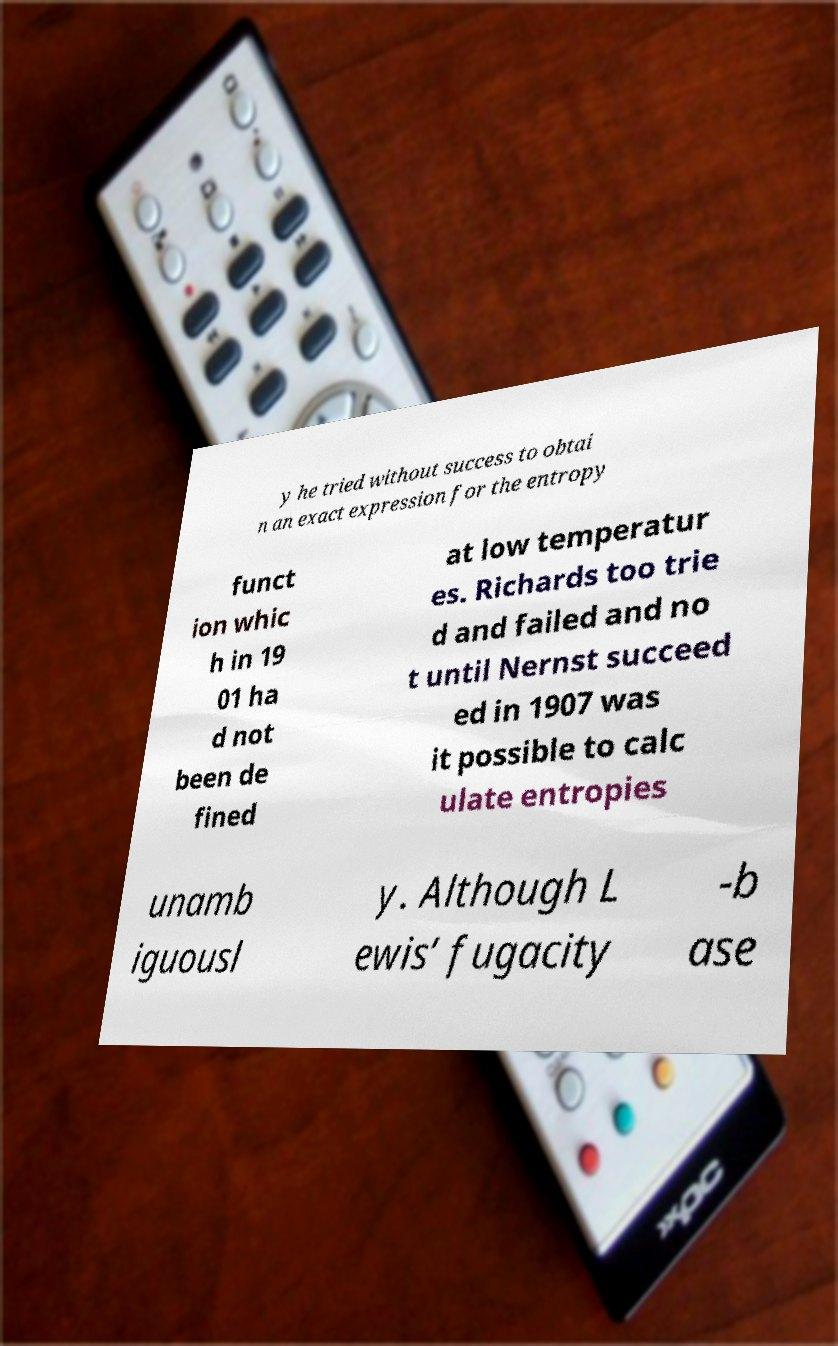Can you accurately transcribe the text from the provided image for me? y he tried without success to obtai n an exact expression for the entropy funct ion whic h in 19 01 ha d not been de fined at low temperatur es. Richards too trie d and failed and no t until Nernst succeed ed in 1907 was it possible to calc ulate entropies unamb iguousl y. Although L ewis’ fugacity -b ase 